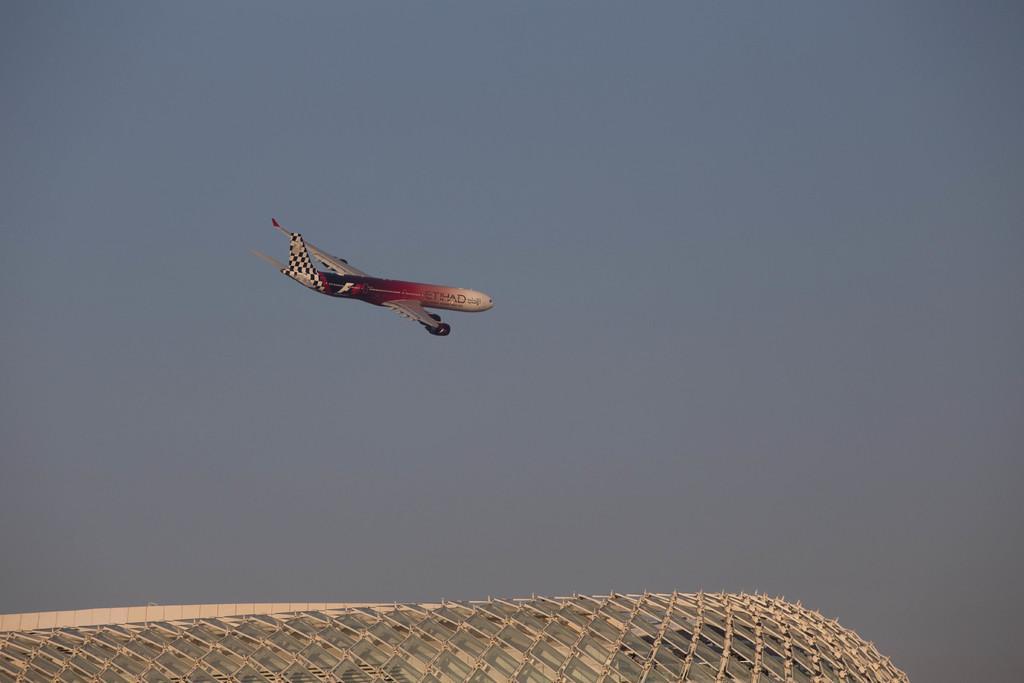In one or two sentences, can you explain what this image depicts? In the center of the image we can see an airplane flying in the sky. At the bottom of the image we can see a roof of a building with some metal poles. 